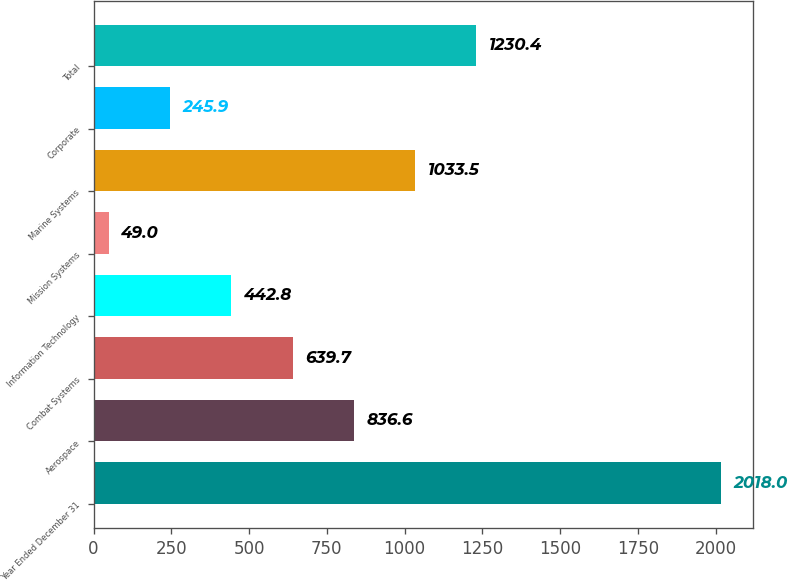Convert chart. <chart><loc_0><loc_0><loc_500><loc_500><bar_chart><fcel>Year Ended December 31<fcel>Aerospace<fcel>Combat Systems<fcel>Information Technology<fcel>Mission Systems<fcel>Marine Systems<fcel>Corporate<fcel>Total<nl><fcel>2018<fcel>836.6<fcel>639.7<fcel>442.8<fcel>49<fcel>1033.5<fcel>245.9<fcel>1230.4<nl></chart> 